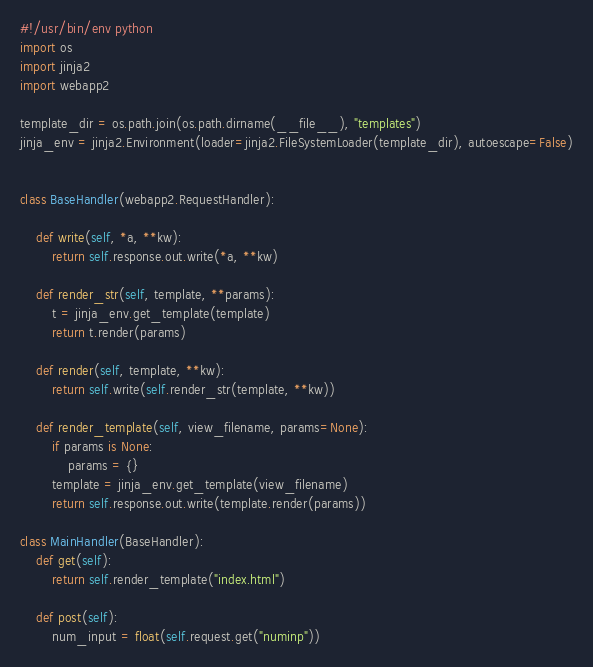Convert code to text. <code><loc_0><loc_0><loc_500><loc_500><_Python_>#!/usr/bin/env python
import os
import jinja2
import webapp2

template_dir = os.path.join(os.path.dirname(__file__), "templates")
jinja_env = jinja2.Environment(loader=jinja2.FileSystemLoader(template_dir), autoescape=False)


class BaseHandler(webapp2.RequestHandler):

    def write(self, *a, **kw):
        return self.response.out.write(*a, **kw)

    def render_str(self, template, **params):
        t = jinja_env.get_template(template)
        return t.render(params)

    def render(self, template, **kw):
        return self.write(self.render_str(template, **kw))

    def render_template(self, view_filename, params=None):
        if params is None:
            params = {}
        template = jinja_env.get_template(view_filename)
        return self.response.out.write(template.render(params))

class MainHandler(BaseHandler):
    def get(self):
        return self.render_template("index.html")

    def post(self):
        num_input = float(self.request.get("numinp"))</code> 